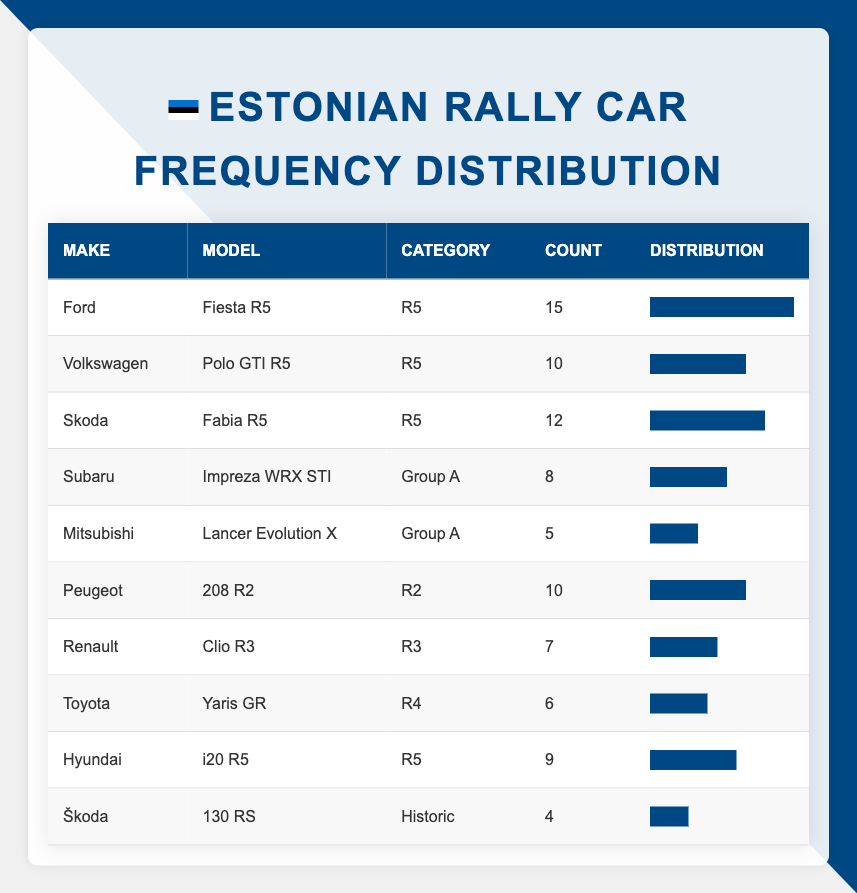What is the most participated rally car in Estonian competitions? The table shows that the Ford Fiesta R5 has the highest count of 15, making it the most participated car.
Answer: Ford Fiesta R5 How many R5 category cars were there in total? To find this, we will sum the counts of all cars in the R5 category: 15 (Ford) + 10 (Volkswagen) + 12 (Skoda) + 9 (Hyundai) = 46.
Answer: 46 Is there a rally car from the Group A category that has more than 7 participants? According to the table, the Subaru Impreza WRX STI has 8 participants, which is indeed more than 7.
Answer: Yes What is the total number of participants across all rally cars in local Estonian competitions? We will sum all the counts from the table: 15 + 10 + 12 + 8 + 5 + 10 + 7 + 6 + 9 + 4 = 76. Thus, the total number of participants is 76.
Answer: 76 Which type of rally car has the least participation? The table indicates that the Škoda 130 RS from the Historic category has the lowest count with only 4 participants.
Answer: Škoda 130 RS What is the average number of participants for the R2 category cars? The R2 category has one car, the Peugeot 208 R2 with 10 participants. Since there is only one data point, the average is simply 10.
Answer: 10 Are there more than two types of rally cars in the R5 category? The table lists four cars (Ford, Volkswagen, Skoda, and Hyundai) under the R5 category, indicating that there are indeed more than two types.
Answer: Yes What percentage of the total participants do the R4 category cars represent? There is one car in the R4 category (Toyota Yaris GR) with 6 participants. The total is 76, so the percentage is (6/76)*100 ≈ 7.89%.
Answer: Approximately 7.89% What is the difference in the number of participants between the highest and lowest participating car? The highest participating car is the Ford Fiesta R5 with 15 participants and the lowest is the Škoda 130 RS with 4 participants. The difference is 15 - 4 = 11.
Answer: 11 